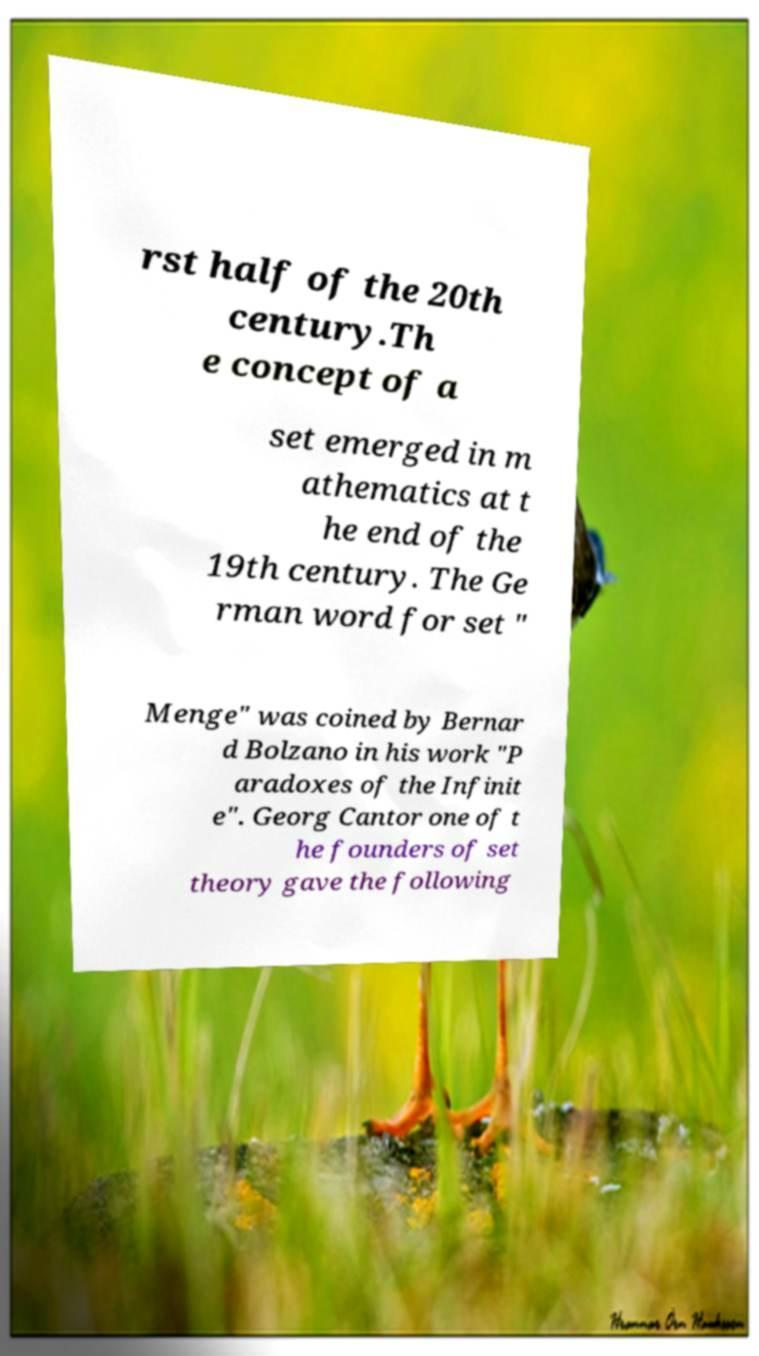Please read and relay the text visible in this image. What does it say? rst half of the 20th century.Th e concept of a set emerged in m athematics at t he end of the 19th century. The Ge rman word for set " Menge" was coined by Bernar d Bolzano in his work "P aradoxes of the Infinit e". Georg Cantor one of t he founders of set theory gave the following 